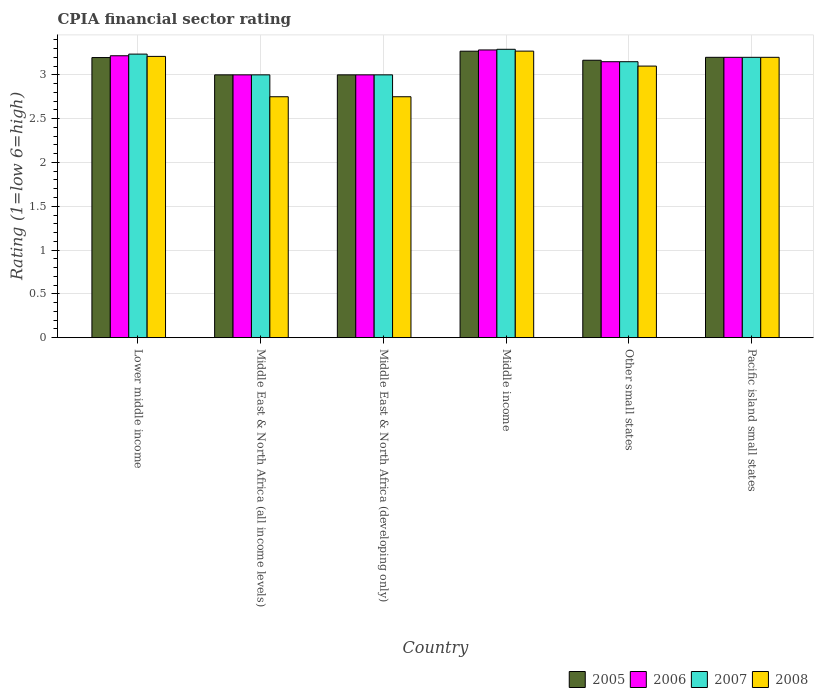Are the number of bars per tick equal to the number of legend labels?
Your answer should be very brief. Yes. How many bars are there on the 4th tick from the left?
Offer a terse response. 4. What is the label of the 4th group of bars from the left?
Give a very brief answer. Middle income. Across all countries, what is the maximum CPIA rating in 2006?
Your answer should be very brief. 3.28. Across all countries, what is the minimum CPIA rating in 2007?
Offer a terse response. 3. In which country was the CPIA rating in 2008 minimum?
Keep it short and to the point. Middle East & North Africa (all income levels). What is the total CPIA rating in 2006 in the graph?
Your answer should be compact. 18.85. What is the difference between the CPIA rating in 2007 in Middle East & North Africa (all income levels) and that in Pacific island small states?
Provide a short and direct response. -0.2. What is the difference between the CPIA rating in 2006 in Pacific island small states and the CPIA rating in 2008 in Other small states?
Make the answer very short. 0.1. What is the average CPIA rating in 2006 per country?
Your response must be concise. 3.14. In how many countries, is the CPIA rating in 2008 greater than 1.5?
Your answer should be compact. 6. What is the ratio of the CPIA rating in 2007 in Middle East & North Africa (developing only) to that in Middle income?
Provide a succinct answer. 0.91. Is the difference between the CPIA rating in 2008 in Middle income and Other small states greater than the difference between the CPIA rating in 2005 in Middle income and Other small states?
Your answer should be very brief. Yes. What is the difference between the highest and the second highest CPIA rating in 2006?
Offer a terse response. -0.07. What is the difference between the highest and the lowest CPIA rating in 2007?
Give a very brief answer. 0.29. In how many countries, is the CPIA rating in 2008 greater than the average CPIA rating in 2008 taken over all countries?
Your response must be concise. 4. Is it the case that in every country, the sum of the CPIA rating in 2006 and CPIA rating in 2005 is greater than the sum of CPIA rating in 2007 and CPIA rating in 2008?
Offer a very short reply. No. Is it the case that in every country, the sum of the CPIA rating in 2006 and CPIA rating in 2005 is greater than the CPIA rating in 2007?
Provide a short and direct response. Yes. How many bars are there?
Your answer should be compact. 24. Are the values on the major ticks of Y-axis written in scientific E-notation?
Your answer should be very brief. No. Does the graph contain any zero values?
Give a very brief answer. No. Does the graph contain grids?
Give a very brief answer. Yes. How many legend labels are there?
Your answer should be compact. 4. What is the title of the graph?
Ensure brevity in your answer.  CPIA financial sector rating. Does "2015" appear as one of the legend labels in the graph?
Keep it short and to the point. No. What is the label or title of the X-axis?
Make the answer very short. Country. What is the Rating (1=low 6=high) of 2005 in Lower middle income?
Offer a very short reply. 3.2. What is the Rating (1=low 6=high) of 2006 in Lower middle income?
Make the answer very short. 3.22. What is the Rating (1=low 6=high) of 2007 in Lower middle income?
Give a very brief answer. 3.24. What is the Rating (1=low 6=high) in 2008 in Lower middle income?
Provide a succinct answer. 3.21. What is the Rating (1=low 6=high) of 2005 in Middle East & North Africa (all income levels)?
Offer a terse response. 3. What is the Rating (1=low 6=high) in 2008 in Middle East & North Africa (all income levels)?
Provide a short and direct response. 2.75. What is the Rating (1=low 6=high) of 2007 in Middle East & North Africa (developing only)?
Your response must be concise. 3. What is the Rating (1=low 6=high) in 2008 in Middle East & North Africa (developing only)?
Your answer should be compact. 2.75. What is the Rating (1=low 6=high) in 2005 in Middle income?
Offer a very short reply. 3.27. What is the Rating (1=low 6=high) of 2006 in Middle income?
Ensure brevity in your answer.  3.28. What is the Rating (1=low 6=high) of 2007 in Middle income?
Keep it short and to the point. 3.29. What is the Rating (1=low 6=high) in 2008 in Middle income?
Provide a short and direct response. 3.27. What is the Rating (1=low 6=high) in 2005 in Other small states?
Provide a succinct answer. 3.17. What is the Rating (1=low 6=high) of 2006 in Other small states?
Provide a short and direct response. 3.15. What is the Rating (1=low 6=high) of 2007 in Other small states?
Offer a terse response. 3.15. What is the Rating (1=low 6=high) in 2005 in Pacific island small states?
Make the answer very short. 3.2. What is the Rating (1=low 6=high) of 2006 in Pacific island small states?
Your response must be concise. 3.2. Across all countries, what is the maximum Rating (1=low 6=high) of 2005?
Ensure brevity in your answer.  3.27. Across all countries, what is the maximum Rating (1=low 6=high) in 2006?
Offer a terse response. 3.28. Across all countries, what is the maximum Rating (1=low 6=high) in 2007?
Ensure brevity in your answer.  3.29. Across all countries, what is the maximum Rating (1=low 6=high) in 2008?
Ensure brevity in your answer.  3.27. Across all countries, what is the minimum Rating (1=low 6=high) of 2008?
Offer a terse response. 2.75. What is the total Rating (1=low 6=high) in 2005 in the graph?
Your answer should be compact. 18.83. What is the total Rating (1=low 6=high) of 2006 in the graph?
Your answer should be very brief. 18.85. What is the total Rating (1=low 6=high) in 2007 in the graph?
Offer a terse response. 18.88. What is the total Rating (1=low 6=high) in 2008 in the graph?
Give a very brief answer. 18.28. What is the difference between the Rating (1=low 6=high) of 2005 in Lower middle income and that in Middle East & North Africa (all income levels)?
Provide a short and direct response. 0.2. What is the difference between the Rating (1=low 6=high) of 2006 in Lower middle income and that in Middle East & North Africa (all income levels)?
Provide a short and direct response. 0.22. What is the difference between the Rating (1=low 6=high) of 2007 in Lower middle income and that in Middle East & North Africa (all income levels)?
Your response must be concise. 0.24. What is the difference between the Rating (1=low 6=high) of 2008 in Lower middle income and that in Middle East & North Africa (all income levels)?
Your answer should be compact. 0.46. What is the difference between the Rating (1=low 6=high) of 2005 in Lower middle income and that in Middle East & North Africa (developing only)?
Your answer should be compact. 0.2. What is the difference between the Rating (1=low 6=high) of 2006 in Lower middle income and that in Middle East & North Africa (developing only)?
Provide a short and direct response. 0.22. What is the difference between the Rating (1=low 6=high) in 2007 in Lower middle income and that in Middle East & North Africa (developing only)?
Ensure brevity in your answer.  0.24. What is the difference between the Rating (1=low 6=high) of 2008 in Lower middle income and that in Middle East & North Africa (developing only)?
Your answer should be very brief. 0.46. What is the difference between the Rating (1=low 6=high) of 2005 in Lower middle income and that in Middle income?
Offer a very short reply. -0.07. What is the difference between the Rating (1=low 6=high) of 2006 in Lower middle income and that in Middle income?
Provide a short and direct response. -0.07. What is the difference between the Rating (1=low 6=high) of 2007 in Lower middle income and that in Middle income?
Ensure brevity in your answer.  -0.05. What is the difference between the Rating (1=low 6=high) of 2008 in Lower middle income and that in Middle income?
Make the answer very short. -0.06. What is the difference between the Rating (1=low 6=high) of 2005 in Lower middle income and that in Other small states?
Offer a very short reply. 0.03. What is the difference between the Rating (1=low 6=high) of 2006 in Lower middle income and that in Other small states?
Your response must be concise. 0.07. What is the difference between the Rating (1=low 6=high) in 2007 in Lower middle income and that in Other small states?
Provide a succinct answer. 0.09. What is the difference between the Rating (1=low 6=high) of 2008 in Lower middle income and that in Other small states?
Make the answer very short. 0.11. What is the difference between the Rating (1=low 6=high) in 2005 in Lower middle income and that in Pacific island small states?
Give a very brief answer. -0. What is the difference between the Rating (1=low 6=high) in 2006 in Lower middle income and that in Pacific island small states?
Give a very brief answer. 0.02. What is the difference between the Rating (1=low 6=high) of 2007 in Lower middle income and that in Pacific island small states?
Provide a short and direct response. 0.04. What is the difference between the Rating (1=low 6=high) of 2008 in Lower middle income and that in Pacific island small states?
Offer a terse response. 0.01. What is the difference between the Rating (1=low 6=high) in 2006 in Middle East & North Africa (all income levels) and that in Middle East & North Africa (developing only)?
Your response must be concise. 0. What is the difference between the Rating (1=low 6=high) of 2007 in Middle East & North Africa (all income levels) and that in Middle East & North Africa (developing only)?
Your answer should be compact. 0. What is the difference between the Rating (1=low 6=high) in 2008 in Middle East & North Africa (all income levels) and that in Middle East & North Africa (developing only)?
Keep it short and to the point. 0. What is the difference between the Rating (1=low 6=high) in 2005 in Middle East & North Africa (all income levels) and that in Middle income?
Give a very brief answer. -0.27. What is the difference between the Rating (1=low 6=high) of 2006 in Middle East & North Africa (all income levels) and that in Middle income?
Make the answer very short. -0.28. What is the difference between the Rating (1=low 6=high) of 2007 in Middle East & North Africa (all income levels) and that in Middle income?
Your response must be concise. -0.29. What is the difference between the Rating (1=low 6=high) in 2008 in Middle East & North Africa (all income levels) and that in Middle income?
Provide a short and direct response. -0.52. What is the difference between the Rating (1=low 6=high) in 2008 in Middle East & North Africa (all income levels) and that in Other small states?
Keep it short and to the point. -0.35. What is the difference between the Rating (1=low 6=high) in 2007 in Middle East & North Africa (all income levels) and that in Pacific island small states?
Your response must be concise. -0.2. What is the difference between the Rating (1=low 6=high) in 2008 in Middle East & North Africa (all income levels) and that in Pacific island small states?
Make the answer very short. -0.45. What is the difference between the Rating (1=low 6=high) of 2005 in Middle East & North Africa (developing only) and that in Middle income?
Your response must be concise. -0.27. What is the difference between the Rating (1=low 6=high) in 2006 in Middle East & North Africa (developing only) and that in Middle income?
Your response must be concise. -0.28. What is the difference between the Rating (1=low 6=high) in 2007 in Middle East & North Africa (developing only) and that in Middle income?
Keep it short and to the point. -0.29. What is the difference between the Rating (1=low 6=high) of 2008 in Middle East & North Africa (developing only) and that in Middle income?
Ensure brevity in your answer.  -0.52. What is the difference between the Rating (1=low 6=high) in 2007 in Middle East & North Africa (developing only) and that in Other small states?
Make the answer very short. -0.15. What is the difference between the Rating (1=low 6=high) in 2008 in Middle East & North Africa (developing only) and that in Other small states?
Ensure brevity in your answer.  -0.35. What is the difference between the Rating (1=low 6=high) in 2006 in Middle East & North Africa (developing only) and that in Pacific island small states?
Ensure brevity in your answer.  -0.2. What is the difference between the Rating (1=low 6=high) of 2007 in Middle East & North Africa (developing only) and that in Pacific island small states?
Offer a terse response. -0.2. What is the difference between the Rating (1=low 6=high) in 2008 in Middle East & North Africa (developing only) and that in Pacific island small states?
Your answer should be very brief. -0.45. What is the difference between the Rating (1=low 6=high) of 2005 in Middle income and that in Other small states?
Provide a succinct answer. 0.1. What is the difference between the Rating (1=low 6=high) in 2006 in Middle income and that in Other small states?
Your response must be concise. 0.13. What is the difference between the Rating (1=low 6=high) in 2007 in Middle income and that in Other small states?
Offer a terse response. 0.14. What is the difference between the Rating (1=low 6=high) in 2008 in Middle income and that in Other small states?
Your answer should be compact. 0.17. What is the difference between the Rating (1=low 6=high) of 2005 in Middle income and that in Pacific island small states?
Your response must be concise. 0.07. What is the difference between the Rating (1=low 6=high) in 2006 in Middle income and that in Pacific island small states?
Offer a terse response. 0.08. What is the difference between the Rating (1=low 6=high) of 2007 in Middle income and that in Pacific island small states?
Your response must be concise. 0.09. What is the difference between the Rating (1=low 6=high) in 2008 in Middle income and that in Pacific island small states?
Your response must be concise. 0.07. What is the difference between the Rating (1=low 6=high) of 2005 in Other small states and that in Pacific island small states?
Offer a terse response. -0.03. What is the difference between the Rating (1=low 6=high) of 2007 in Other small states and that in Pacific island small states?
Give a very brief answer. -0.05. What is the difference between the Rating (1=low 6=high) of 2005 in Lower middle income and the Rating (1=low 6=high) of 2006 in Middle East & North Africa (all income levels)?
Provide a short and direct response. 0.2. What is the difference between the Rating (1=low 6=high) in 2005 in Lower middle income and the Rating (1=low 6=high) in 2007 in Middle East & North Africa (all income levels)?
Offer a terse response. 0.2. What is the difference between the Rating (1=low 6=high) in 2005 in Lower middle income and the Rating (1=low 6=high) in 2008 in Middle East & North Africa (all income levels)?
Give a very brief answer. 0.45. What is the difference between the Rating (1=low 6=high) in 2006 in Lower middle income and the Rating (1=low 6=high) in 2007 in Middle East & North Africa (all income levels)?
Your response must be concise. 0.22. What is the difference between the Rating (1=low 6=high) of 2006 in Lower middle income and the Rating (1=low 6=high) of 2008 in Middle East & North Africa (all income levels)?
Make the answer very short. 0.47. What is the difference between the Rating (1=low 6=high) in 2007 in Lower middle income and the Rating (1=low 6=high) in 2008 in Middle East & North Africa (all income levels)?
Your answer should be very brief. 0.49. What is the difference between the Rating (1=low 6=high) in 2005 in Lower middle income and the Rating (1=low 6=high) in 2006 in Middle East & North Africa (developing only)?
Offer a very short reply. 0.2. What is the difference between the Rating (1=low 6=high) of 2005 in Lower middle income and the Rating (1=low 6=high) of 2007 in Middle East & North Africa (developing only)?
Offer a terse response. 0.2. What is the difference between the Rating (1=low 6=high) of 2005 in Lower middle income and the Rating (1=low 6=high) of 2008 in Middle East & North Africa (developing only)?
Offer a terse response. 0.45. What is the difference between the Rating (1=low 6=high) of 2006 in Lower middle income and the Rating (1=low 6=high) of 2007 in Middle East & North Africa (developing only)?
Ensure brevity in your answer.  0.22. What is the difference between the Rating (1=low 6=high) in 2006 in Lower middle income and the Rating (1=low 6=high) in 2008 in Middle East & North Africa (developing only)?
Offer a very short reply. 0.47. What is the difference between the Rating (1=low 6=high) of 2007 in Lower middle income and the Rating (1=low 6=high) of 2008 in Middle East & North Africa (developing only)?
Make the answer very short. 0.49. What is the difference between the Rating (1=low 6=high) of 2005 in Lower middle income and the Rating (1=low 6=high) of 2006 in Middle income?
Provide a succinct answer. -0.09. What is the difference between the Rating (1=low 6=high) of 2005 in Lower middle income and the Rating (1=low 6=high) of 2007 in Middle income?
Make the answer very short. -0.09. What is the difference between the Rating (1=low 6=high) in 2005 in Lower middle income and the Rating (1=low 6=high) in 2008 in Middle income?
Your answer should be compact. -0.07. What is the difference between the Rating (1=low 6=high) of 2006 in Lower middle income and the Rating (1=low 6=high) of 2007 in Middle income?
Offer a terse response. -0.07. What is the difference between the Rating (1=low 6=high) in 2006 in Lower middle income and the Rating (1=low 6=high) in 2008 in Middle income?
Ensure brevity in your answer.  -0.05. What is the difference between the Rating (1=low 6=high) of 2007 in Lower middle income and the Rating (1=low 6=high) of 2008 in Middle income?
Provide a succinct answer. -0.03. What is the difference between the Rating (1=low 6=high) in 2005 in Lower middle income and the Rating (1=low 6=high) in 2006 in Other small states?
Offer a very short reply. 0.05. What is the difference between the Rating (1=low 6=high) in 2005 in Lower middle income and the Rating (1=low 6=high) in 2007 in Other small states?
Offer a very short reply. 0.05. What is the difference between the Rating (1=low 6=high) in 2005 in Lower middle income and the Rating (1=low 6=high) in 2008 in Other small states?
Keep it short and to the point. 0.1. What is the difference between the Rating (1=low 6=high) in 2006 in Lower middle income and the Rating (1=low 6=high) in 2007 in Other small states?
Make the answer very short. 0.07. What is the difference between the Rating (1=low 6=high) of 2006 in Lower middle income and the Rating (1=low 6=high) of 2008 in Other small states?
Your answer should be very brief. 0.12. What is the difference between the Rating (1=low 6=high) in 2007 in Lower middle income and the Rating (1=low 6=high) in 2008 in Other small states?
Your answer should be very brief. 0.14. What is the difference between the Rating (1=low 6=high) in 2005 in Lower middle income and the Rating (1=low 6=high) in 2006 in Pacific island small states?
Your answer should be very brief. -0. What is the difference between the Rating (1=low 6=high) of 2005 in Lower middle income and the Rating (1=low 6=high) of 2007 in Pacific island small states?
Ensure brevity in your answer.  -0. What is the difference between the Rating (1=low 6=high) of 2005 in Lower middle income and the Rating (1=low 6=high) of 2008 in Pacific island small states?
Your answer should be compact. -0. What is the difference between the Rating (1=low 6=high) in 2006 in Lower middle income and the Rating (1=low 6=high) in 2007 in Pacific island small states?
Give a very brief answer. 0.02. What is the difference between the Rating (1=low 6=high) of 2006 in Lower middle income and the Rating (1=low 6=high) of 2008 in Pacific island small states?
Ensure brevity in your answer.  0.02. What is the difference between the Rating (1=low 6=high) of 2007 in Lower middle income and the Rating (1=low 6=high) of 2008 in Pacific island small states?
Keep it short and to the point. 0.04. What is the difference between the Rating (1=low 6=high) of 2005 in Middle East & North Africa (all income levels) and the Rating (1=low 6=high) of 2006 in Middle East & North Africa (developing only)?
Make the answer very short. 0. What is the difference between the Rating (1=low 6=high) in 2005 in Middle East & North Africa (all income levels) and the Rating (1=low 6=high) in 2007 in Middle East & North Africa (developing only)?
Provide a succinct answer. 0. What is the difference between the Rating (1=low 6=high) in 2005 in Middle East & North Africa (all income levels) and the Rating (1=low 6=high) in 2008 in Middle East & North Africa (developing only)?
Make the answer very short. 0.25. What is the difference between the Rating (1=low 6=high) of 2006 in Middle East & North Africa (all income levels) and the Rating (1=low 6=high) of 2007 in Middle East & North Africa (developing only)?
Provide a succinct answer. 0. What is the difference between the Rating (1=low 6=high) in 2006 in Middle East & North Africa (all income levels) and the Rating (1=low 6=high) in 2008 in Middle East & North Africa (developing only)?
Provide a succinct answer. 0.25. What is the difference between the Rating (1=low 6=high) in 2005 in Middle East & North Africa (all income levels) and the Rating (1=low 6=high) in 2006 in Middle income?
Your response must be concise. -0.28. What is the difference between the Rating (1=low 6=high) in 2005 in Middle East & North Africa (all income levels) and the Rating (1=low 6=high) in 2007 in Middle income?
Provide a short and direct response. -0.29. What is the difference between the Rating (1=low 6=high) of 2005 in Middle East & North Africa (all income levels) and the Rating (1=low 6=high) of 2008 in Middle income?
Provide a succinct answer. -0.27. What is the difference between the Rating (1=low 6=high) in 2006 in Middle East & North Africa (all income levels) and the Rating (1=low 6=high) in 2007 in Middle income?
Provide a succinct answer. -0.29. What is the difference between the Rating (1=low 6=high) of 2006 in Middle East & North Africa (all income levels) and the Rating (1=low 6=high) of 2008 in Middle income?
Your response must be concise. -0.27. What is the difference between the Rating (1=low 6=high) of 2007 in Middle East & North Africa (all income levels) and the Rating (1=low 6=high) of 2008 in Middle income?
Offer a very short reply. -0.27. What is the difference between the Rating (1=low 6=high) in 2005 in Middle East & North Africa (all income levels) and the Rating (1=low 6=high) in 2007 in Other small states?
Keep it short and to the point. -0.15. What is the difference between the Rating (1=low 6=high) of 2005 in Middle East & North Africa (all income levels) and the Rating (1=low 6=high) of 2008 in Other small states?
Your answer should be compact. -0.1. What is the difference between the Rating (1=low 6=high) of 2006 in Middle East & North Africa (all income levels) and the Rating (1=low 6=high) of 2007 in Other small states?
Your answer should be compact. -0.15. What is the difference between the Rating (1=low 6=high) in 2006 in Middle East & North Africa (all income levels) and the Rating (1=low 6=high) in 2008 in Other small states?
Your answer should be very brief. -0.1. What is the difference between the Rating (1=low 6=high) in 2005 in Middle East & North Africa (all income levels) and the Rating (1=low 6=high) in 2006 in Pacific island small states?
Provide a short and direct response. -0.2. What is the difference between the Rating (1=low 6=high) in 2005 in Middle East & North Africa (all income levels) and the Rating (1=low 6=high) in 2008 in Pacific island small states?
Provide a succinct answer. -0.2. What is the difference between the Rating (1=low 6=high) of 2006 in Middle East & North Africa (all income levels) and the Rating (1=low 6=high) of 2007 in Pacific island small states?
Give a very brief answer. -0.2. What is the difference between the Rating (1=low 6=high) in 2007 in Middle East & North Africa (all income levels) and the Rating (1=low 6=high) in 2008 in Pacific island small states?
Offer a very short reply. -0.2. What is the difference between the Rating (1=low 6=high) of 2005 in Middle East & North Africa (developing only) and the Rating (1=low 6=high) of 2006 in Middle income?
Make the answer very short. -0.28. What is the difference between the Rating (1=low 6=high) in 2005 in Middle East & North Africa (developing only) and the Rating (1=low 6=high) in 2007 in Middle income?
Offer a very short reply. -0.29. What is the difference between the Rating (1=low 6=high) of 2005 in Middle East & North Africa (developing only) and the Rating (1=low 6=high) of 2008 in Middle income?
Keep it short and to the point. -0.27. What is the difference between the Rating (1=low 6=high) in 2006 in Middle East & North Africa (developing only) and the Rating (1=low 6=high) in 2007 in Middle income?
Offer a terse response. -0.29. What is the difference between the Rating (1=low 6=high) in 2006 in Middle East & North Africa (developing only) and the Rating (1=low 6=high) in 2008 in Middle income?
Make the answer very short. -0.27. What is the difference between the Rating (1=low 6=high) of 2007 in Middle East & North Africa (developing only) and the Rating (1=low 6=high) of 2008 in Middle income?
Offer a very short reply. -0.27. What is the difference between the Rating (1=low 6=high) in 2006 in Middle East & North Africa (developing only) and the Rating (1=low 6=high) in 2007 in Other small states?
Make the answer very short. -0.15. What is the difference between the Rating (1=low 6=high) of 2006 in Middle East & North Africa (developing only) and the Rating (1=low 6=high) of 2008 in Other small states?
Your answer should be compact. -0.1. What is the difference between the Rating (1=low 6=high) in 2007 in Middle East & North Africa (developing only) and the Rating (1=low 6=high) in 2008 in Other small states?
Keep it short and to the point. -0.1. What is the difference between the Rating (1=low 6=high) of 2005 in Middle East & North Africa (developing only) and the Rating (1=low 6=high) of 2006 in Pacific island small states?
Your response must be concise. -0.2. What is the difference between the Rating (1=low 6=high) of 2005 in Middle East & North Africa (developing only) and the Rating (1=low 6=high) of 2008 in Pacific island small states?
Provide a short and direct response. -0.2. What is the difference between the Rating (1=low 6=high) of 2006 in Middle East & North Africa (developing only) and the Rating (1=low 6=high) of 2007 in Pacific island small states?
Your response must be concise. -0.2. What is the difference between the Rating (1=low 6=high) in 2007 in Middle East & North Africa (developing only) and the Rating (1=low 6=high) in 2008 in Pacific island small states?
Ensure brevity in your answer.  -0.2. What is the difference between the Rating (1=low 6=high) in 2005 in Middle income and the Rating (1=low 6=high) in 2006 in Other small states?
Offer a very short reply. 0.12. What is the difference between the Rating (1=low 6=high) in 2005 in Middle income and the Rating (1=low 6=high) in 2007 in Other small states?
Keep it short and to the point. 0.12. What is the difference between the Rating (1=low 6=high) in 2005 in Middle income and the Rating (1=low 6=high) in 2008 in Other small states?
Give a very brief answer. 0.17. What is the difference between the Rating (1=low 6=high) of 2006 in Middle income and the Rating (1=low 6=high) of 2007 in Other small states?
Offer a very short reply. 0.13. What is the difference between the Rating (1=low 6=high) of 2006 in Middle income and the Rating (1=low 6=high) of 2008 in Other small states?
Your answer should be very brief. 0.18. What is the difference between the Rating (1=low 6=high) in 2007 in Middle income and the Rating (1=low 6=high) in 2008 in Other small states?
Provide a succinct answer. 0.19. What is the difference between the Rating (1=low 6=high) in 2005 in Middle income and the Rating (1=low 6=high) in 2006 in Pacific island small states?
Your answer should be very brief. 0.07. What is the difference between the Rating (1=low 6=high) of 2005 in Middle income and the Rating (1=low 6=high) of 2007 in Pacific island small states?
Provide a succinct answer. 0.07. What is the difference between the Rating (1=low 6=high) of 2005 in Middle income and the Rating (1=low 6=high) of 2008 in Pacific island small states?
Offer a terse response. 0.07. What is the difference between the Rating (1=low 6=high) of 2006 in Middle income and the Rating (1=low 6=high) of 2007 in Pacific island small states?
Give a very brief answer. 0.08. What is the difference between the Rating (1=low 6=high) of 2006 in Middle income and the Rating (1=low 6=high) of 2008 in Pacific island small states?
Provide a succinct answer. 0.08. What is the difference between the Rating (1=low 6=high) of 2007 in Middle income and the Rating (1=low 6=high) of 2008 in Pacific island small states?
Your answer should be very brief. 0.09. What is the difference between the Rating (1=low 6=high) of 2005 in Other small states and the Rating (1=low 6=high) of 2006 in Pacific island small states?
Keep it short and to the point. -0.03. What is the difference between the Rating (1=low 6=high) of 2005 in Other small states and the Rating (1=low 6=high) of 2007 in Pacific island small states?
Provide a succinct answer. -0.03. What is the difference between the Rating (1=low 6=high) in 2005 in Other small states and the Rating (1=low 6=high) in 2008 in Pacific island small states?
Your answer should be compact. -0.03. What is the difference between the Rating (1=low 6=high) in 2006 in Other small states and the Rating (1=low 6=high) in 2007 in Pacific island small states?
Give a very brief answer. -0.05. What is the difference between the Rating (1=low 6=high) in 2007 in Other small states and the Rating (1=low 6=high) in 2008 in Pacific island small states?
Give a very brief answer. -0.05. What is the average Rating (1=low 6=high) in 2005 per country?
Your answer should be very brief. 3.14. What is the average Rating (1=low 6=high) of 2006 per country?
Provide a succinct answer. 3.14. What is the average Rating (1=low 6=high) of 2007 per country?
Your answer should be very brief. 3.15. What is the average Rating (1=low 6=high) in 2008 per country?
Offer a very short reply. 3.05. What is the difference between the Rating (1=low 6=high) of 2005 and Rating (1=low 6=high) of 2006 in Lower middle income?
Your answer should be compact. -0.02. What is the difference between the Rating (1=low 6=high) of 2005 and Rating (1=low 6=high) of 2007 in Lower middle income?
Provide a succinct answer. -0.04. What is the difference between the Rating (1=low 6=high) in 2005 and Rating (1=low 6=high) in 2008 in Lower middle income?
Offer a terse response. -0.01. What is the difference between the Rating (1=low 6=high) in 2006 and Rating (1=low 6=high) in 2007 in Lower middle income?
Offer a very short reply. -0.02. What is the difference between the Rating (1=low 6=high) of 2006 and Rating (1=low 6=high) of 2008 in Lower middle income?
Offer a very short reply. 0.01. What is the difference between the Rating (1=low 6=high) of 2007 and Rating (1=low 6=high) of 2008 in Lower middle income?
Offer a terse response. 0.03. What is the difference between the Rating (1=low 6=high) in 2005 and Rating (1=low 6=high) in 2006 in Middle East & North Africa (all income levels)?
Offer a terse response. 0. What is the difference between the Rating (1=low 6=high) of 2005 and Rating (1=low 6=high) of 2007 in Middle East & North Africa (all income levels)?
Your answer should be compact. 0. What is the difference between the Rating (1=low 6=high) in 2005 and Rating (1=low 6=high) in 2008 in Middle East & North Africa (all income levels)?
Provide a succinct answer. 0.25. What is the difference between the Rating (1=low 6=high) of 2006 and Rating (1=low 6=high) of 2008 in Middle East & North Africa (all income levels)?
Make the answer very short. 0.25. What is the difference between the Rating (1=low 6=high) in 2007 and Rating (1=low 6=high) in 2008 in Middle East & North Africa (all income levels)?
Provide a short and direct response. 0.25. What is the difference between the Rating (1=low 6=high) of 2005 and Rating (1=low 6=high) of 2006 in Middle East & North Africa (developing only)?
Make the answer very short. 0. What is the difference between the Rating (1=low 6=high) in 2005 and Rating (1=low 6=high) in 2007 in Middle East & North Africa (developing only)?
Give a very brief answer. 0. What is the difference between the Rating (1=low 6=high) in 2005 and Rating (1=low 6=high) in 2008 in Middle East & North Africa (developing only)?
Keep it short and to the point. 0.25. What is the difference between the Rating (1=low 6=high) in 2006 and Rating (1=low 6=high) in 2008 in Middle East & North Africa (developing only)?
Keep it short and to the point. 0.25. What is the difference between the Rating (1=low 6=high) of 2005 and Rating (1=low 6=high) of 2006 in Middle income?
Offer a very short reply. -0.01. What is the difference between the Rating (1=low 6=high) in 2005 and Rating (1=low 6=high) in 2007 in Middle income?
Offer a terse response. -0.02. What is the difference between the Rating (1=low 6=high) in 2005 and Rating (1=low 6=high) in 2008 in Middle income?
Give a very brief answer. -0. What is the difference between the Rating (1=low 6=high) of 2006 and Rating (1=low 6=high) of 2007 in Middle income?
Your response must be concise. -0.01. What is the difference between the Rating (1=low 6=high) in 2006 and Rating (1=low 6=high) in 2008 in Middle income?
Your response must be concise. 0.01. What is the difference between the Rating (1=low 6=high) in 2007 and Rating (1=low 6=high) in 2008 in Middle income?
Your answer should be compact. 0.02. What is the difference between the Rating (1=low 6=high) in 2005 and Rating (1=low 6=high) in 2006 in Other small states?
Your answer should be very brief. 0.02. What is the difference between the Rating (1=low 6=high) of 2005 and Rating (1=low 6=high) of 2007 in Other small states?
Your answer should be compact. 0.02. What is the difference between the Rating (1=low 6=high) in 2005 and Rating (1=low 6=high) in 2008 in Other small states?
Provide a short and direct response. 0.07. What is the difference between the Rating (1=low 6=high) of 2007 and Rating (1=low 6=high) of 2008 in Other small states?
Keep it short and to the point. 0.05. What is the difference between the Rating (1=low 6=high) in 2005 and Rating (1=low 6=high) in 2006 in Pacific island small states?
Ensure brevity in your answer.  0. What is the difference between the Rating (1=low 6=high) of 2005 and Rating (1=low 6=high) of 2007 in Pacific island small states?
Ensure brevity in your answer.  0. What is the ratio of the Rating (1=low 6=high) of 2005 in Lower middle income to that in Middle East & North Africa (all income levels)?
Your answer should be compact. 1.07. What is the ratio of the Rating (1=low 6=high) of 2006 in Lower middle income to that in Middle East & North Africa (all income levels)?
Your response must be concise. 1.07. What is the ratio of the Rating (1=low 6=high) of 2007 in Lower middle income to that in Middle East & North Africa (all income levels)?
Make the answer very short. 1.08. What is the ratio of the Rating (1=low 6=high) of 2008 in Lower middle income to that in Middle East & North Africa (all income levels)?
Your answer should be very brief. 1.17. What is the ratio of the Rating (1=low 6=high) of 2005 in Lower middle income to that in Middle East & North Africa (developing only)?
Give a very brief answer. 1.07. What is the ratio of the Rating (1=low 6=high) in 2006 in Lower middle income to that in Middle East & North Africa (developing only)?
Give a very brief answer. 1.07. What is the ratio of the Rating (1=low 6=high) in 2007 in Lower middle income to that in Middle East & North Africa (developing only)?
Your response must be concise. 1.08. What is the ratio of the Rating (1=low 6=high) of 2008 in Lower middle income to that in Middle East & North Africa (developing only)?
Your answer should be very brief. 1.17. What is the ratio of the Rating (1=low 6=high) in 2005 in Lower middle income to that in Middle income?
Your response must be concise. 0.98. What is the ratio of the Rating (1=low 6=high) in 2006 in Lower middle income to that in Middle income?
Your answer should be compact. 0.98. What is the ratio of the Rating (1=low 6=high) of 2007 in Lower middle income to that in Middle income?
Your answer should be compact. 0.98. What is the ratio of the Rating (1=low 6=high) of 2008 in Lower middle income to that in Middle income?
Offer a very short reply. 0.98. What is the ratio of the Rating (1=low 6=high) in 2005 in Lower middle income to that in Other small states?
Ensure brevity in your answer.  1.01. What is the ratio of the Rating (1=low 6=high) in 2006 in Lower middle income to that in Other small states?
Your answer should be compact. 1.02. What is the ratio of the Rating (1=low 6=high) of 2007 in Lower middle income to that in Other small states?
Keep it short and to the point. 1.03. What is the ratio of the Rating (1=low 6=high) of 2008 in Lower middle income to that in Other small states?
Keep it short and to the point. 1.04. What is the ratio of the Rating (1=low 6=high) in 2005 in Lower middle income to that in Pacific island small states?
Your response must be concise. 1. What is the ratio of the Rating (1=low 6=high) in 2006 in Lower middle income to that in Pacific island small states?
Your response must be concise. 1.01. What is the ratio of the Rating (1=low 6=high) of 2007 in Lower middle income to that in Pacific island small states?
Ensure brevity in your answer.  1.01. What is the ratio of the Rating (1=low 6=high) of 2006 in Middle East & North Africa (all income levels) to that in Middle East & North Africa (developing only)?
Give a very brief answer. 1. What is the ratio of the Rating (1=low 6=high) in 2007 in Middle East & North Africa (all income levels) to that in Middle East & North Africa (developing only)?
Ensure brevity in your answer.  1. What is the ratio of the Rating (1=low 6=high) in 2008 in Middle East & North Africa (all income levels) to that in Middle East & North Africa (developing only)?
Give a very brief answer. 1. What is the ratio of the Rating (1=low 6=high) of 2005 in Middle East & North Africa (all income levels) to that in Middle income?
Your response must be concise. 0.92. What is the ratio of the Rating (1=low 6=high) of 2006 in Middle East & North Africa (all income levels) to that in Middle income?
Provide a short and direct response. 0.91. What is the ratio of the Rating (1=low 6=high) in 2007 in Middle East & North Africa (all income levels) to that in Middle income?
Your answer should be compact. 0.91. What is the ratio of the Rating (1=low 6=high) in 2008 in Middle East & North Africa (all income levels) to that in Middle income?
Offer a very short reply. 0.84. What is the ratio of the Rating (1=low 6=high) in 2006 in Middle East & North Africa (all income levels) to that in Other small states?
Give a very brief answer. 0.95. What is the ratio of the Rating (1=low 6=high) in 2008 in Middle East & North Africa (all income levels) to that in Other small states?
Offer a terse response. 0.89. What is the ratio of the Rating (1=low 6=high) in 2005 in Middle East & North Africa (all income levels) to that in Pacific island small states?
Provide a short and direct response. 0.94. What is the ratio of the Rating (1=low 6=high) of 2006 in Middle East & North Africa (all income levels) to that in Pacific island small states?
Give a very brief answer. 0.94. What is the ratio of the Rating (1=low 6=high) of 2007 in Middle East & North Africa (all income levels) to that in Pacific island small states?
Offer a terse response. 0.94. What is the ratio of the Rating (1=low 6=high) in 2008 in Middle East & North Africa (all income levels) to that in Pacific island small states?
Give a very brief answer. 0.86. What is the ratio of the Rating (1=low 6=high) in 2005 in Middle East & North Africa (developing only) to that in Middle income?
Offer a very short reply. 0.92. What is the ratio of the Rating (1=low 6=high) of 2006 in Middle East & North Africa (developing only) to that in Middle income?
Provide a succinct answer. 0.91. What is the ratio of the Rating (1=low 6=high) of 2007 in Middle East & North Africa (developing only) to that in Middle income?
Make the answer very short. 0.91. What is the ratio of the Rating (1=low 6=high) in 2008 in Middle East & North Africa (developing only) to that in Middle income?
Make the answer very short. 0.84. What is the ratio of the Rating (1=low 6=high) of 2006 in Middle East & North Africa (developing only) to that in Other small states?
Keep it short and to the point. 0.95. What is the ratio of the Rating (1=low 6=high) in 2008 in Middle East & North Africa (developing only) to that in Other small states?
Make the answer very short. 0.89. What is the ratio of the Rating (1=low 6=high) in 2005 in Middle East & North Africa (developing only) to that in Pacific island small states?
Offer a very short reply. 0.94. What is the ratio of the Rating (1=low 6=high) of 2006 in Middle East & North Africa (developing only) to that in Pacific island small states?
Your answer should be very brief. 0.94. What is the ratio of the Rating (1=low 6=high) of 2008 in Middle East & North Africa (developing only) to that in Pacific island small states?
Keep it short and to the point. 0.86. What is the ratio of the Rating (1=low 6=high) in 2005 in Middle income to that in Other small states?
Provide a short and direct response. 1.03. What is the ratio of the Rating (1=low 6=high) of 2006 in Middle income to that in Other small states?
Your response must be concise. 1.04. What is the ratio of the Rating (1=low 6=high) of 2007 in Middle income to that in Other small states?
Your answer should be compact. 1.04. What is the ratio of the Rating (1=low 6=high) in 2008 in Middle income to that in Other small states?
Ensure brevity in your answer.  1.06. What is the ratio of the Rating (1=low 6=high) of 2005 in Middle income to that in Pacific island small states?
Keep it short and to the point. 1.02. What is the ratio of the Rating (1=low 6=high) in 2006 in Middle income to that in Pacific island small states?
Your answer should be compact. 1.03. What is the ratio of the Rating (1=low 6=high) in 2007 in Middle income to that in Pacific island small states?
Give a very brief answer. 1.03. What is the ratio of the Rating (1=low 6=high) of 2008 in Middle income to that in Pacific island small states?
Offer a very short reply. 1.02. What is the ratio of the Rating (1=low 6=high) in 2005 in Other small states to that in Pacific island small states?
Ensure brevity in your answer.  0.99. What is the ratio of the Rating (1=low 6=high) of 2006 in Other small states to that in Pacific island small states?
Ensure brevity in your answer.  0.98. What is the ratio of the Rating (1=low 6=high) in 2007 in Other small states to that in Pacific island small states?
Your answer should be very brief. 0.98. What is the ratio of the Rating (1=low 6=high) in 2008 in Other small states to that in Pacific island small states?
Make the answer very short. 0.97. What is the difference between the highest and the second highest Rating (1=low 6=high) in 2005?
Your answer should be compact. 0.07. What is the difference between the highest and the second highest Rating (1=low 6=high) in 2006?
Your answer should be compact. 0.07. What is the difference between the highest and the second highest Rating (1=low 6=high) of 2007?
Your answer should be compact. 0.05. What is the difference between the highest and the second highest Rating (1=low 6=high) of 2008?
Ensure brevity in your answer.  0.06. What is the difference between the highest and the lowest Rating (1=low 6=high) of 2005?
Give a very brief answer. 0.27. What is the difference between the highest and the lowest Rating (1=low 6=high) in 2006?
Offer a terse response. 0.28. What is the difference between the highest and the lowest Rating (1=low 6=high) in 2007?
Your response must be concise. 0.29. What is the difference between the highest and the lowest Rating (1=low 6=high) of 2008?
Your response must be concise. 0.52. 